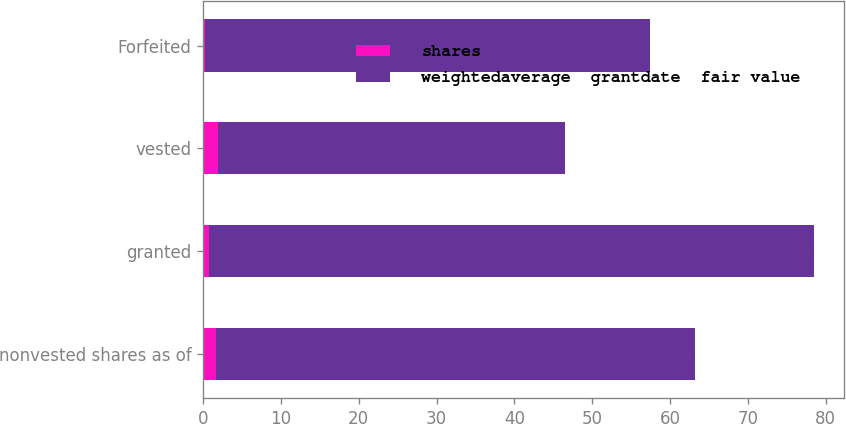<chart> <loc_0><loc_0><loc_500><loc_500><stacked_bar_chart><ecel><fcel>nonvested shares as of<fcel>granted<fcel>vested<fcel>Forfeited<nl><fcel>shares<fcel>1.7<fcel>0.7<fcel>1.9<fcel>0.2<nl><fcel>weightedaverage  grantdate  fair value<fcel>61.56<fcel>77.74<fcel>44.54<fcel>57.26<nl></chart> 